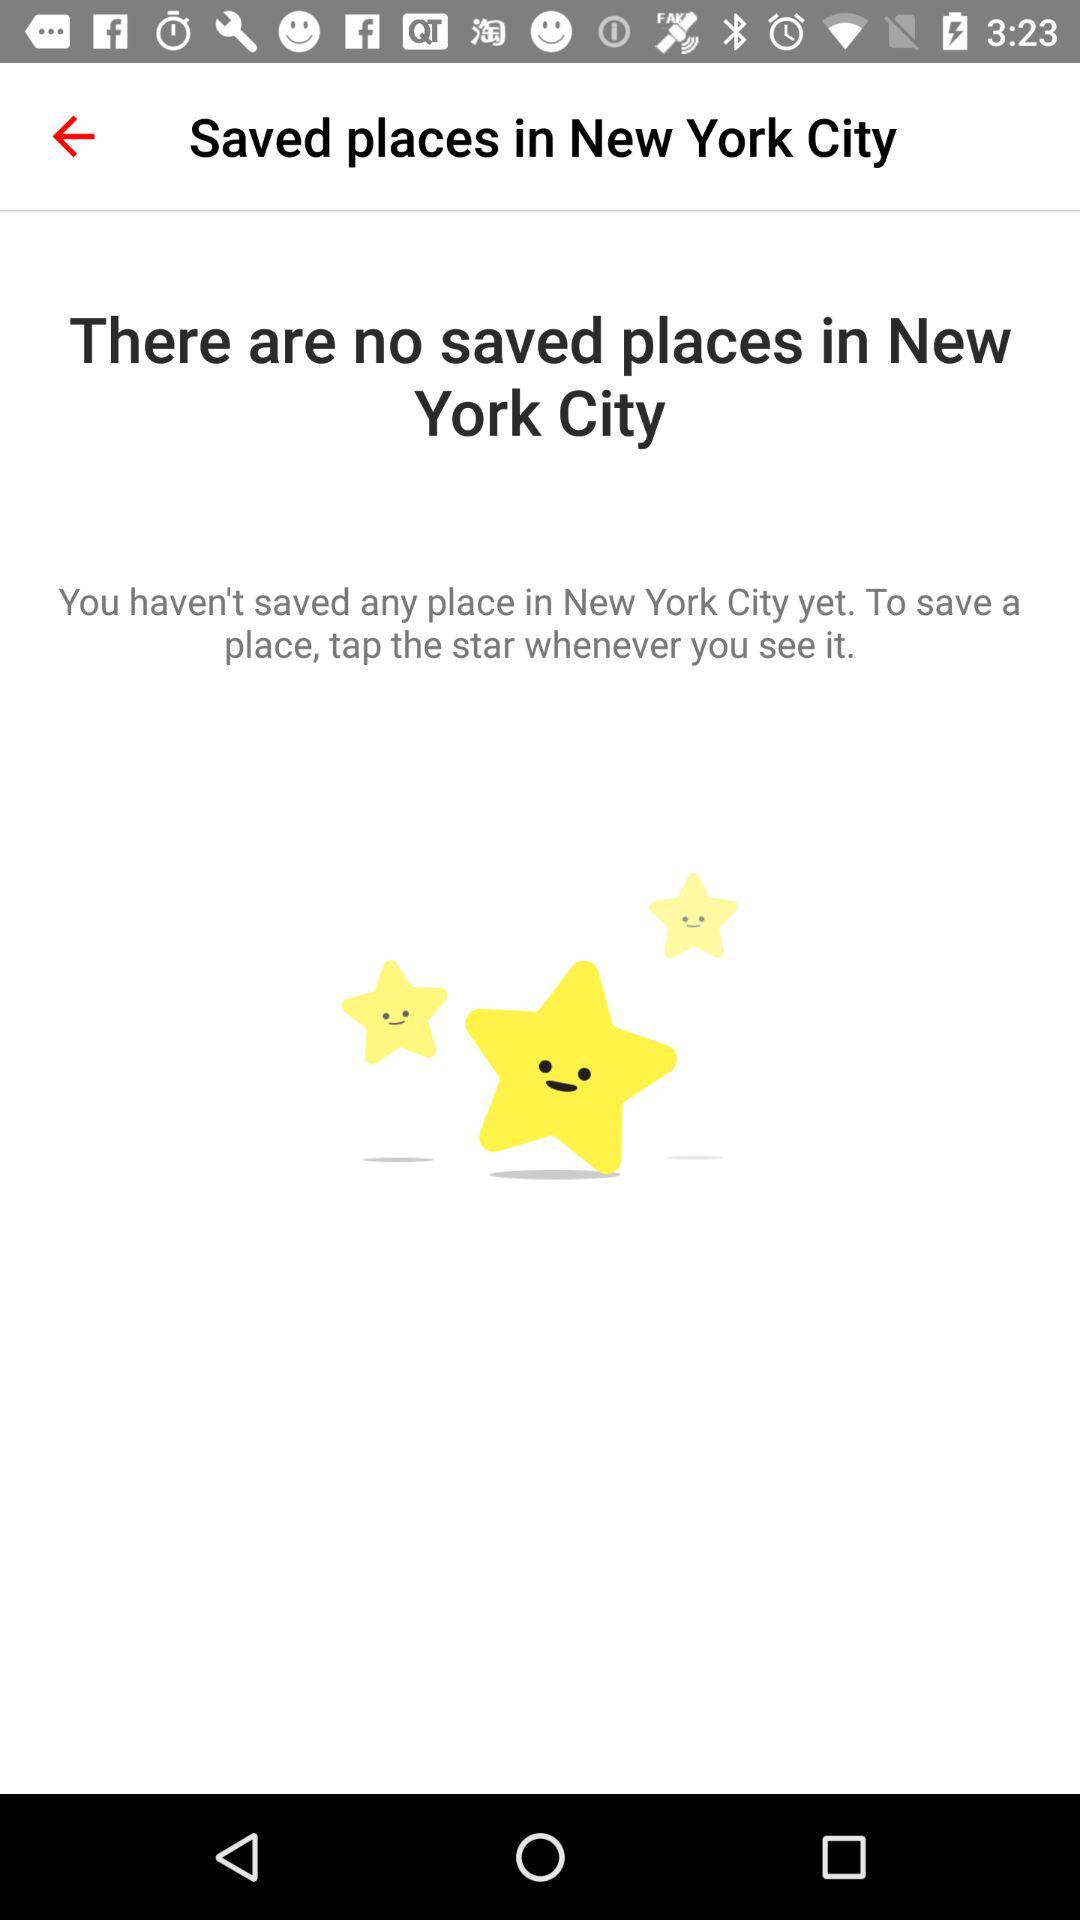How many saved places are there in New York City?
Answer the question using a single word or phrase. 0 